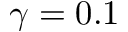Convert formula to latex. <formula><loc_0><loc_0><loc_500><loc_500>\gamma = 0 . 1</formula> 